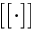<formula> <loc_0><loc_0><loc_500><loc_500>[ [ \cdot ] ]</formula> 